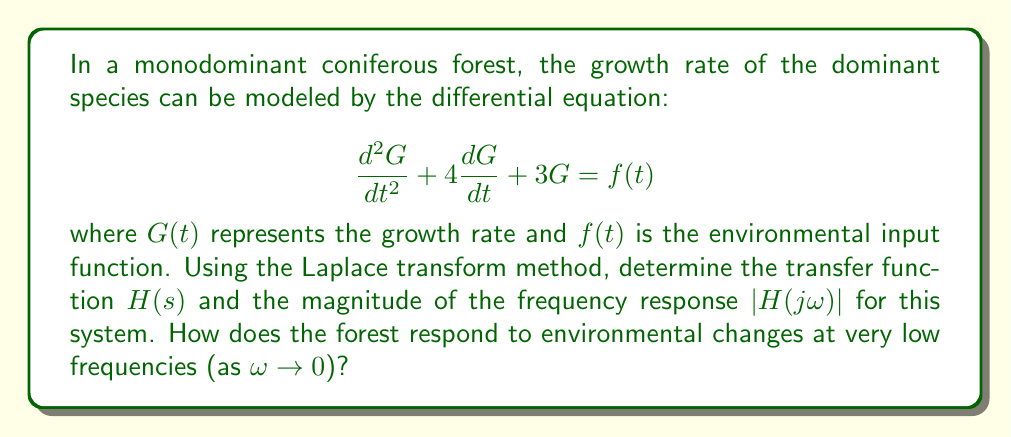Teach me how to tackle this problem. To solve this problem, we'll follow these steps:

1) First, we need to take the Laplace transform of both sides of the differential equation:

   $$\mathcal{L}\{d^2G/dt^2 + 4dG/dt + 3G\} = \mathcal{L}\{f(t)\}$$

2) Using the properties of the Laplace transform:

   $$s^2G(s) - sG(0) - G'(0) + 4[sG(s) - G(0)] + 3G(s) = F(s)$$

3) Assuming initial conditions are zero (G(0) = G'(0) = 0):

   $$s^2G(s) + 4sG(s) + 3G(s) = F(s)$$

4) Factor out G(s):

   $$G(s)(s^2 + 4s + 3) = F(s)$$

5) The transfer function H(s) is defined as the ratio of output to input in the s-domain:

   $$H(s) = \frac{G(s)}{F(s)} = \frac{1}{s^2 + 4s + 3}$$

6) To find the frequency response, we substitute s with jω:

   $$H(j\omega) = \frac{1}{(j\omega)^2 + 4(j\omega) + 3} = \frac{1}{-\omega^2 + 4j\omega + 3}$$

7) The magnitude of the frequency response is:

   $$|H(j\omega)| = \frac{1}{\sqrt{(-\omega^2 + 3)^2 + (4\omega)^2}}$$

8) To examine the response at very low frequencies, we take the limit as ω approaches 0:

   $$\lim_{\omega \to 0} |H(j\omega)| = \lim_{\omega \to 0} \frac{1}{\sqrt{(-\omega^2 + 3)^2 + (4\omega)^2}} = \frac{1}{3}$$

This means that at very low frequencies, the magnitude of the forest's response to environmental changes is 1/3 of the input magnitude.
Answer: The transfer function is $H(s) = \frac{1}{s^2 + 4s + 3}$. The magnitude of the frequency response is $|H(j\omega)| = \frac{1}{\sqrt{(-\omega^2 + 3)^2 + (4\omega)^2}}$. At very low frequencies (as $\omega \to 0$), the forest responds with 1/3 of the magnitude of environmental changes. 